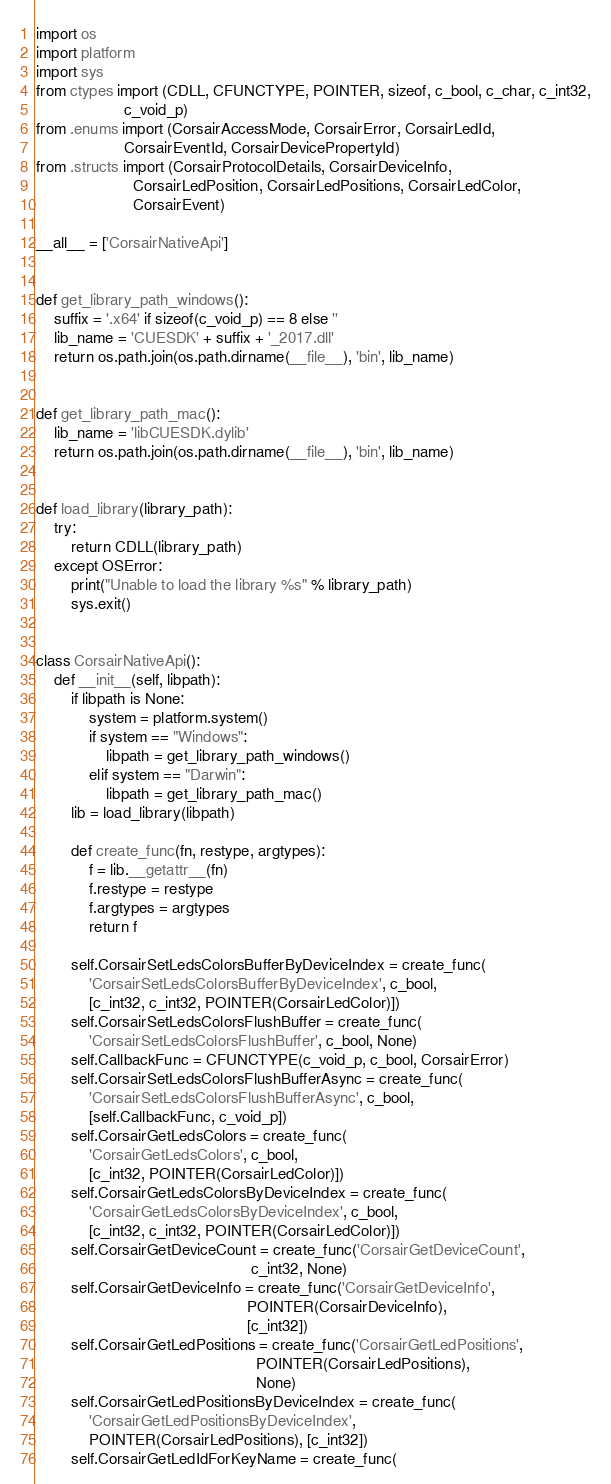<code> <loc_0><loc_0><loc_500><loc_500><_Python_>import os
import platform
import sys
from ctypes import (CDLL, CFUNCTYPE, POINTER, sizeof, c_bool, c_char, c_int32,
                    c_void_p)
from .enums import (CorsairAccessMode, CorsairError, CorsairLedId,
                    CorsairEventId, CorsairDevicePropertyId)
from .structs import (CorsairProtocolDetails, CorsairDeviceInfo,
                      CorsairLedPosition, CorsairLedPositions, CorsairLedColor,
                      CorsairEvent)

__all__ = ['CorsairNativeApi']


def get_library_path_windows():
    suffix = '.x64' if sizeof(c_void_p) == 8 else ''
    lib_name = 'CUESDK' + suffix + '_2017.dll'
    return os.path.join(os.path.dirname(__file__), 'bin', lib_name)


def get_library_path_mac():
    lib_name = 'libCUESDK.dylib'
    return os.path.join(os.path.dirname(__file__), 'bin', lib_name)


def load_library(library_path):
    try:
        return CDLL(library_path)
    except OSError:
        print("Unable to load the library %s" % library_path)
        sys.exit()


class CorsairNativeApi():
    def __init__(self, libpath):
        if libpath is None:
            system = platform.system()
            if system == "Windows":
                libpath = get_library_path_windows()
            elif system == "Darwin":
                libpath = get_library_path_mac()
        lib = load_library(libpath)

        def create_func(fn, restype, argtypes):
            f = lib.__getattr__(fn)
            f.restype = restype
            f.argtypes = argtypes
            return f

        self.CorsairSetLedsColorsBufferByDeviceIndex = create_func(
            'CorsairSetLedsColorsBufferByDeviceIndex', c_bool,
            [c_int32, c_int32, POINTER(CorsairLedColor)])
        self.CorsairSetLedsColorsFlushBuffer = create_func(
            'CorsairSetLedsColorsFlushBuffer', c_bool, None)
        self.CallbackFunc = CFUNCTYPE(c_void_p, c_bool, CorsairError)
        self.CorsairSetLedsColorsFlushBufferAsync = create_func(
            'CorsairSetLedsColorsFlushBufferAsync', c_bool,
            [self.CallbackFunc, c_void_p])
        self.CorsairGetLedsColors = create_func(
            'CorsairGetLedsColors', c_bool,
            [c_int32, POINTER(CorsairLedColor)])
        self.CorsairGetLedsColorsByDeviceIndex = create_func(
            'CorsairGetLedsColorsByDeviceIndex', c_bool,
            [c_int32, c_int32, POINTER(CorsairLedColor)])
        self.CorsairGetDeviceCount = create_func('CorsairGetDeviceCount',
                                                 c_int32, None)
        self.CorsairGetDeviceInfo = create_func('CorsairGetDeviceInfo',
                                                POINTER(CorsairDeviceInfo),
                                                [c_int32])
        self.CorsairGetLedPositions = create_func('CorsairGetLedPositions',
                                                  POINTER(CorsairLedPositions),
                                                  None)
        self.CorsairGetLedPositionsByDeviceIndex = create_func(
            'CorsairGetLedPositionsByDeviceIndex',
            POINTER(CorsairLedPositions), [c_int32])
        self.CorsairGetLedIdForKeyName = create_func(</code> 